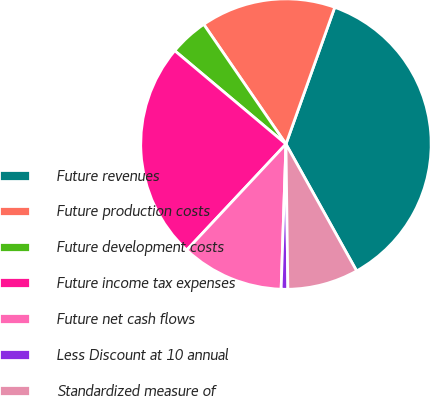Convert chart to OTSL. <chart><loc_0><loc_0><loc_500><loc_500><pie_chart><fcel>Future revenues<fcel>Future production costs<fcel>Future development costs<fcel>Future income tax expenses<fcel>Future net cash flows<fcel>Less Discount at 10 annual<fcel>Standardized measure of<nl><fcel>36.46%<fcel>15.03%<fcel>4.31%<fcel>24.14%<fcel>11.45%<fcel>0.74%<fcel>7.88%<nl></chart> 